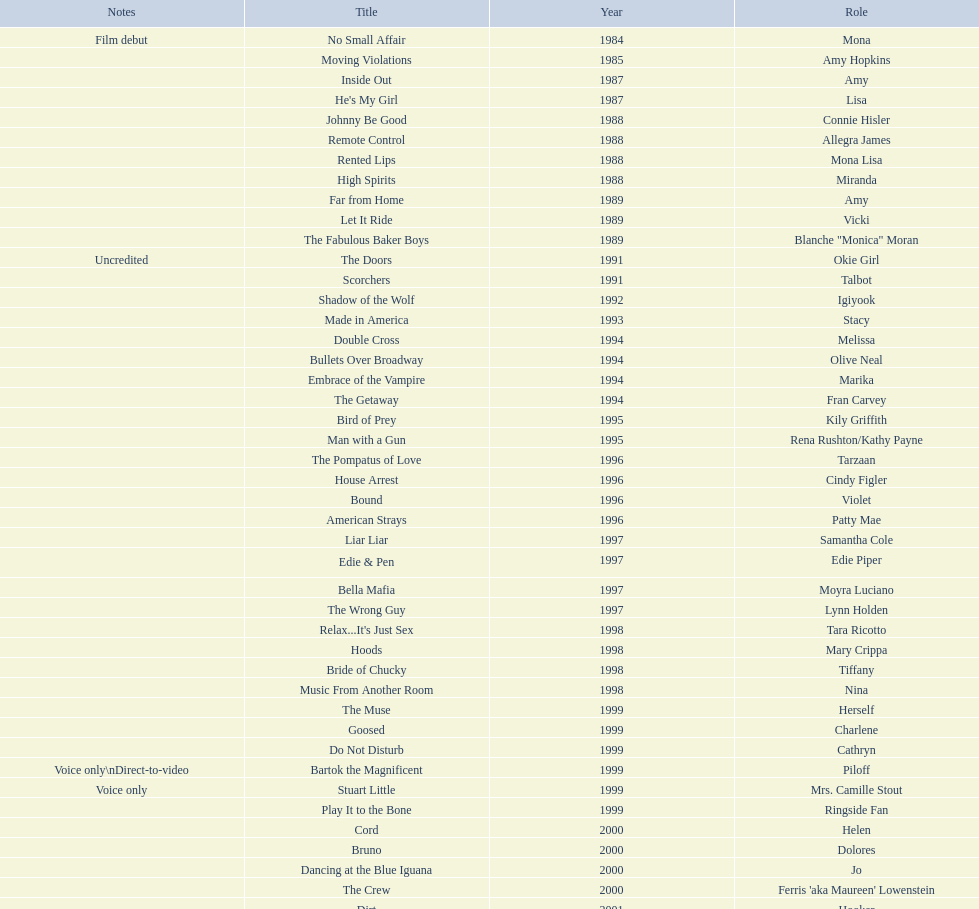Which film has their role under igiyook? Shadow of the Wolf. 